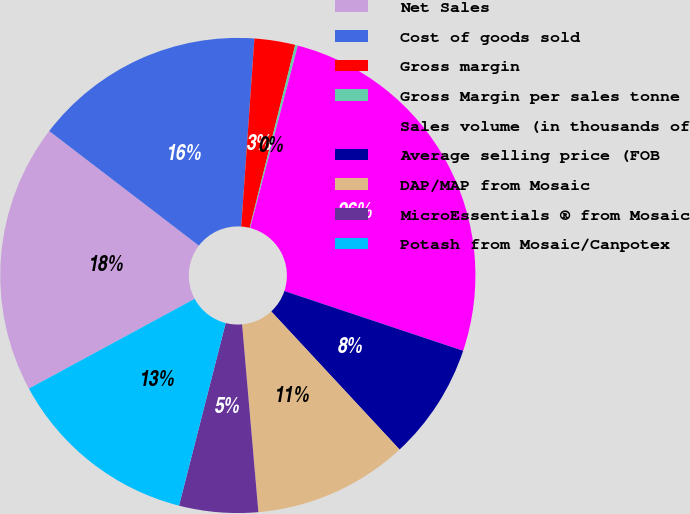<chart> <loc_0><loc_0><loc_500><loc_500><pie_chart><fcel>Net Sales<fcel>Cost of goods sold<fcel>Gross margin<fcel>Gross Margin per sales tonne<fcel>Sales volume (in thousands of<fcel>Average selling price (FOB<fcel>DAP/MAP from Mosaic<fcel>MicroEssentials ® from Mosaic<fcel>Potash from Mosaic/Canpotex<nl><fcel>18.3%<fcel>15.71%<fcel>2.77%<fcel>0.18%<fcel>26.07%<fcel>7.95%<fcel>10.54%<fcel>5.36%<fcel>13.12%<nl></chart> 